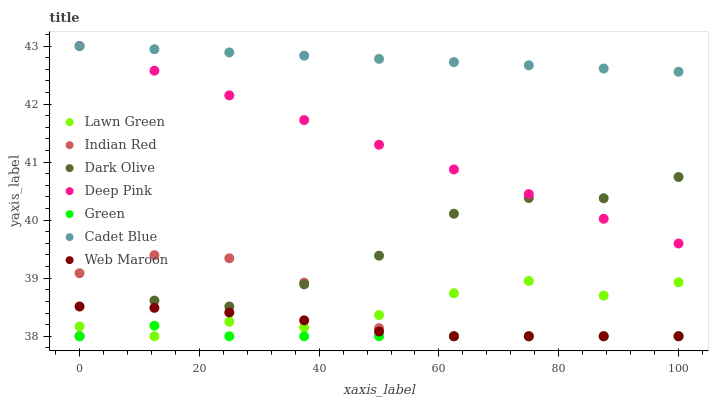Does Green have the minimum area under the curve?
Answer yes or no. Yes. Does Cadet Blue have the maximum area under the curve?
Answer yes or no. Yes. Does Dark Olive have the minimum area under the curve?
Answer yes or no. No. Does Dark Olive have the maximum area under the curve?
Answer yes or no. No. Is Deep Pink the smoothest?
Answer yes or no. Yes. Is Dark Olive the roughest?
Answer yes or no. Yes. Is Cadet Blue the smoothest?
Answer yes or no. No. Is Cadet Blue the roughest?
Answer yes or no. No. Does Lawn Green have the lowest value?
Answer yes or no. Yes. Does Cadet Blue have the lowest value?
Answer yes or no. No. Does Deep Pink have the highest value?
Answer yes or no. Yes. Does Dark Olive have the highest value?
Answer yes or no. No. Is Indian Red less than Cadet Blue?
Answer yes or no. Yes. Is Cadet Blue greater than Green?
Answer yes or no. Yes. Does Green intersect Indian Red?
Answer yes or no. Yes. Is Green less than Indian Red?
Answer yes or no. No. Is Green greater than Indian Red?
Answer yes or no. No. Does Indian Red intersect Cadet Blue?
Answer yes or no. No. 